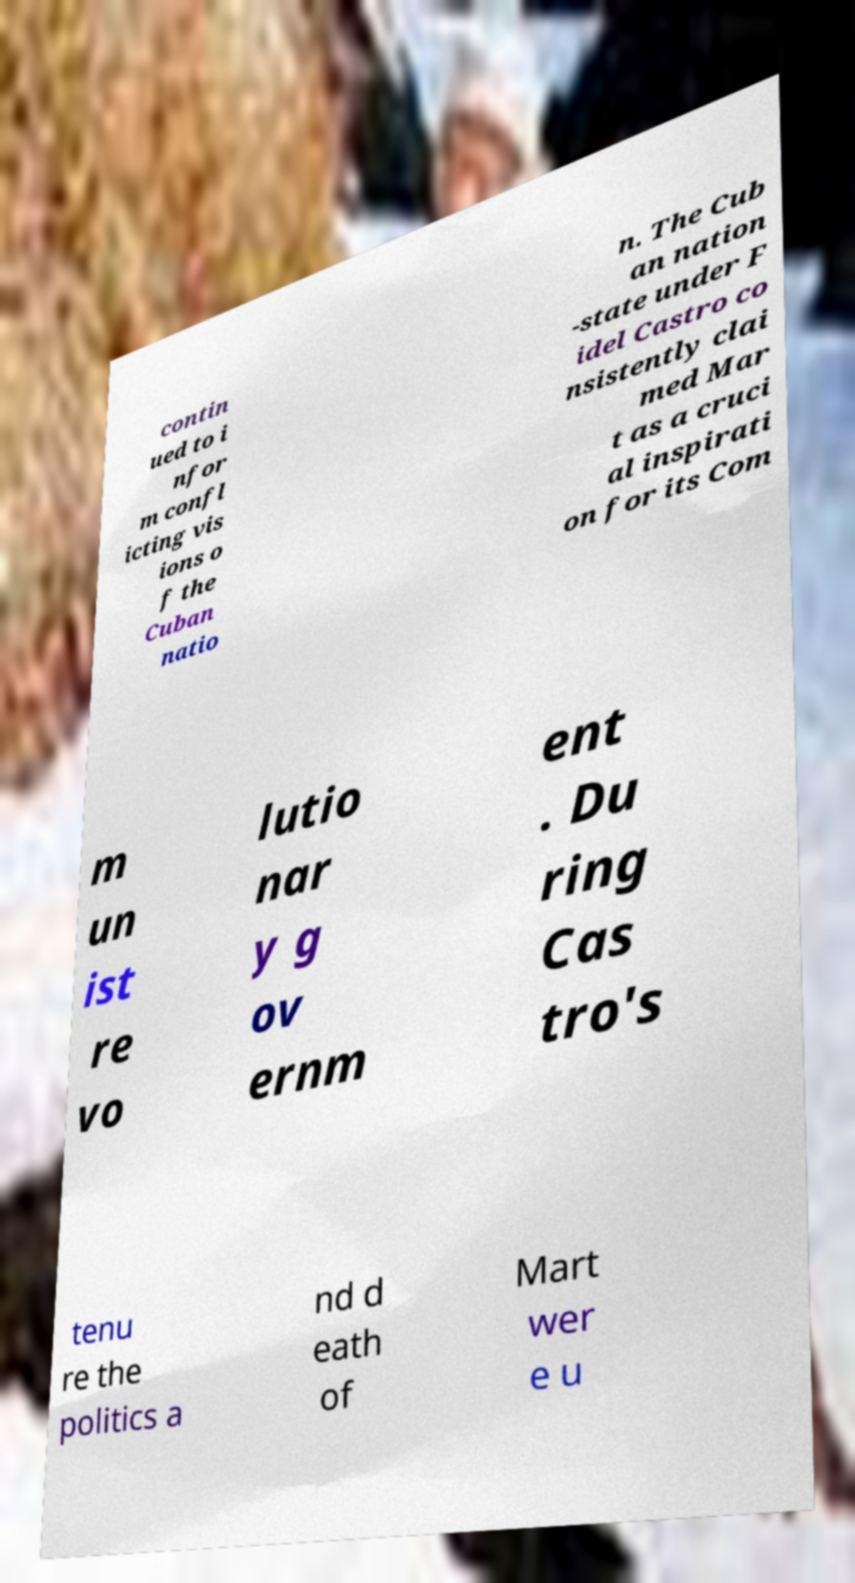For documentation purposes, I need the text within this image transcribed. Could you provide that? contin ued to i nfor m confl icting vis ions o f the Cuban natio n. The Cub an nation -state under F idel Castro co nsistently clai med Mar t as a cruci al inspirati on for its Com m un ist re vo lutio nar y g ov ernm ent . Du ring Cas tro's tenu re the politics a nd d eath of Mart wer e u 